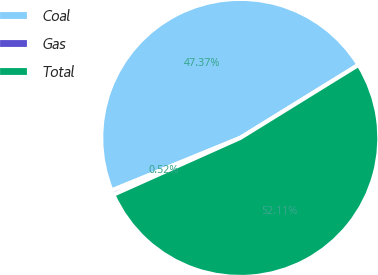<chart> <loc_0><loc_0><loc_500><loc_500><pie_chart><fcel>Coal<fcel>Gas<fcel>Total<nl><fcel>47.37%<fcel>0.52%<fcel>52.11%<nl></chart> 